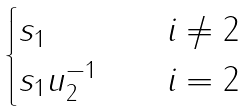<formula> <loc_0><loc_0><loc_500><loc_500>\begin{cases} s _ { 1 } \quad & i \ne 2 \\ s _ { 1 } u _ { 2 } ^ { - 1 } \quad & i = 2 \end{cases}</formula> 